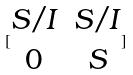Convert formula to latex. <formula><loc_0><loc_0><loc_500><loc_500>[ \begin{matrix} S / I & S / I \\ 0 & S \end{matrix} ]</formula> 